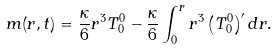<formula> <loc_0><loc_0><loc_500><loc_500>m ( r , t ) = \frac { \kappa } { 6 } r ^ { 3 } T ^ { 0 } _ { 0 } - \frac { \kappa } { 6 } \int ^ { r } _ { 0 } { r ^ { 3 } \left ( T ^ { 0 } _ { 0 } \right ) ^ { \prime } d r } .</formula> 